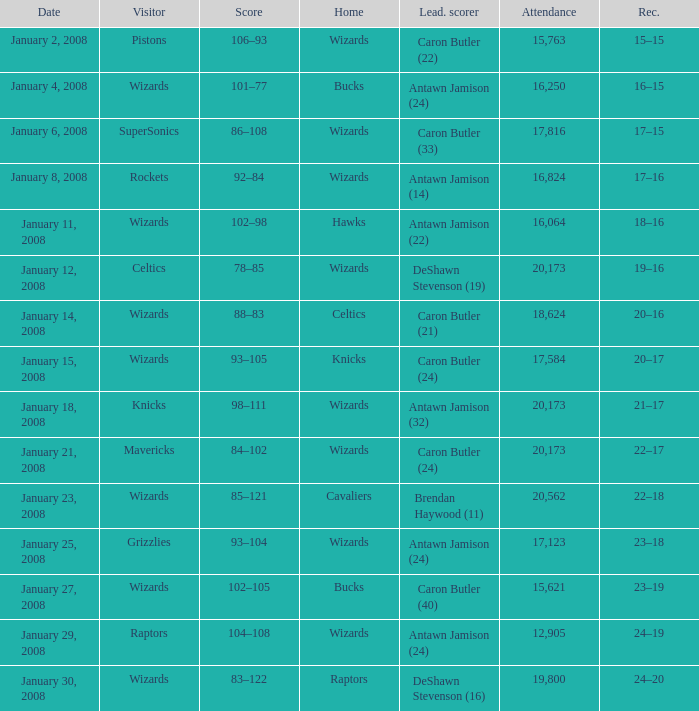What is the record when the leading scorer is Antawn Jamison (14)? 17–16. 